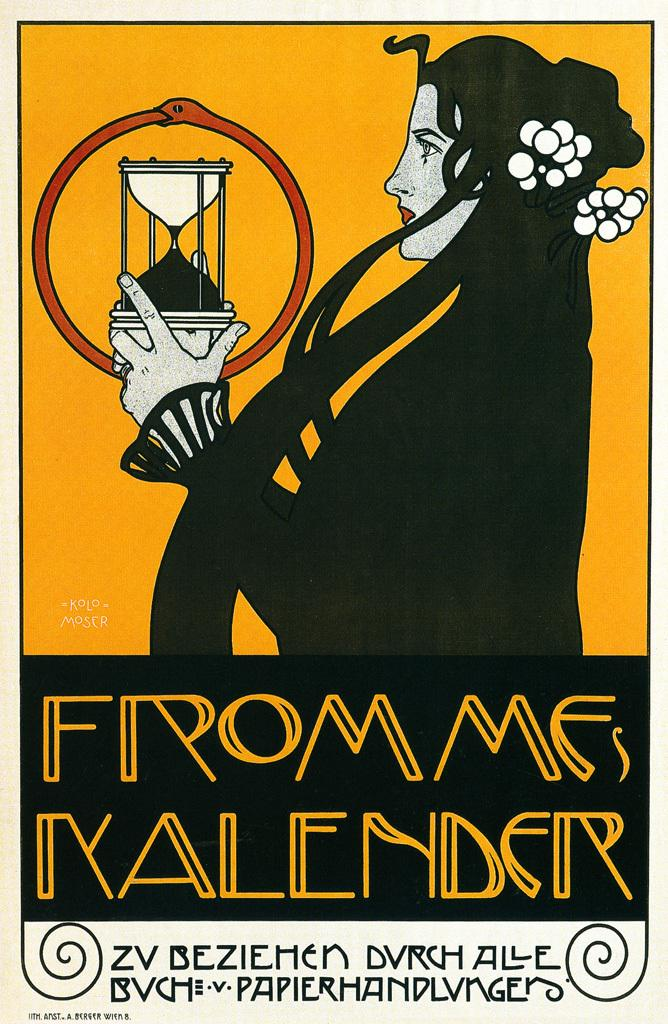<image>
Relay a brief, clear account of the picture shown. A poster for Frommes Kalender shows a woman holding an almost empty hourglass. 